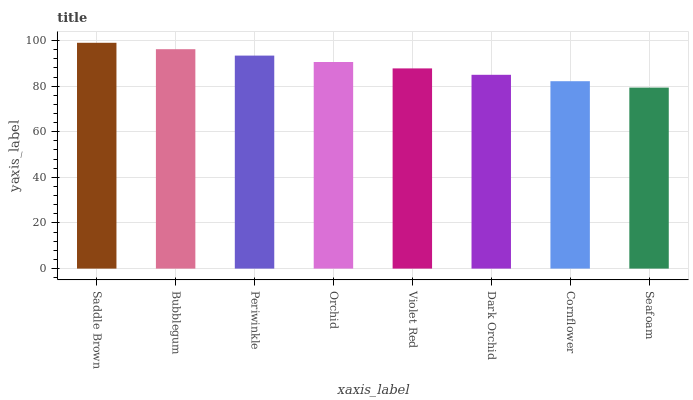Is Seafoam the minimum?
Answer yes or no. Yes. Is Saddle Brown the maximum?
Answer yes or no. Yes. Is Bubblegum the minimum?
Answer yes or no. No. Is Bubblegum the maximum?
Answer yes or no. No. Is Saddle Brown greater than Bubblegum?
Answer yes or no. Yes. Is Bubblegum less than Saddle Brown?
Answer yes or no. Yes. Is Bubblegum greater than Saddle Brown?
Answer yes or no. No. Is Saddle Brown less than Bubblegum?
Answer yes or no. No. Is Orchid the high median?
Answer yes or no. Yes. Is Violet Red the low median?
Answer yes or no. Yes. Is Periwinkle the high median?
Answer yes or no. No. Is Dark Orchid the low median?
Answer yes or no. No. 